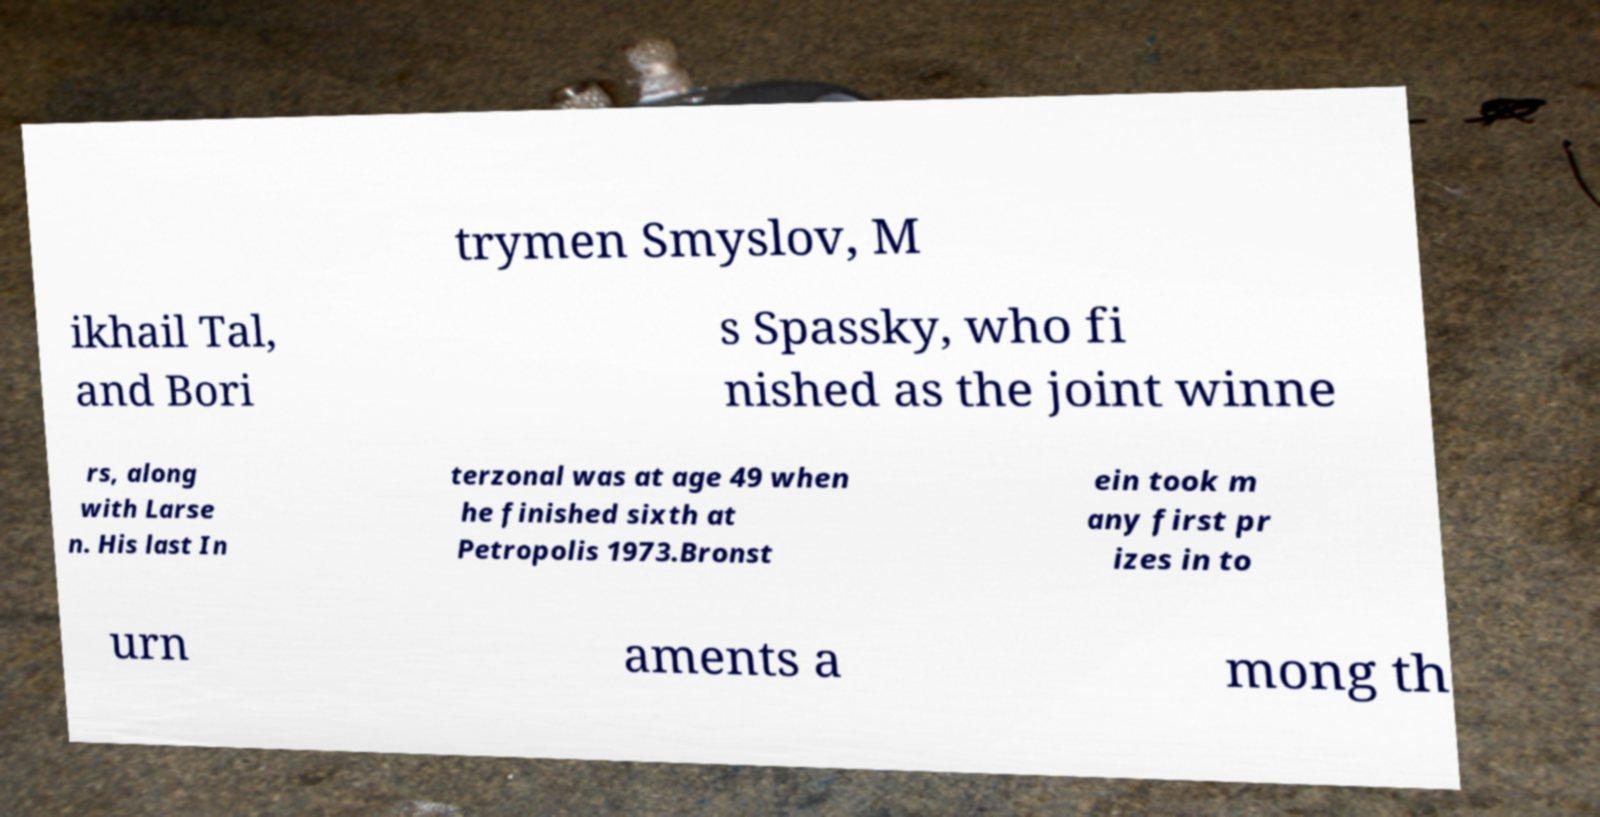Can you read and provide the text displayed in the image?This photo seems to have some interesting text. Can you extract and type it out for me? trymen Smyslov, M ikhail Tal, and Bori s Spassky, who fi nished as the joint winne rs, along with Larse n. His last In terzonal was at age 49 when he finished sixth at Petropolis 1973.Bronst ein took m any first pr izes in to urn aments a mong th 